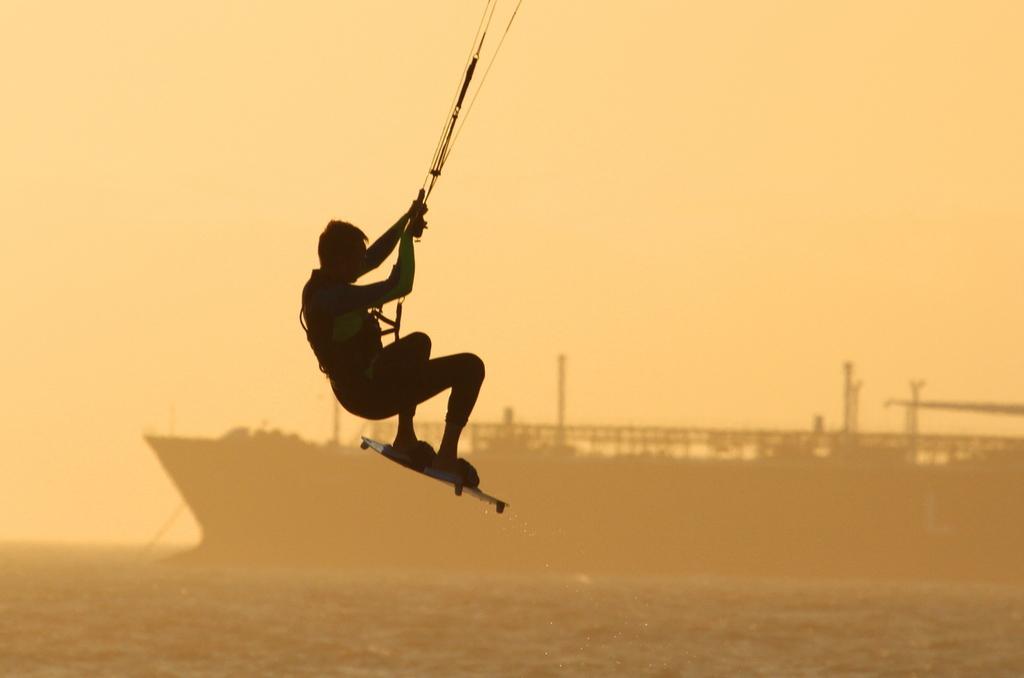Please provide a concise description of this image. here there is a person hanged in the air he is wearing surfing board. In the background there is ship on the water body. 